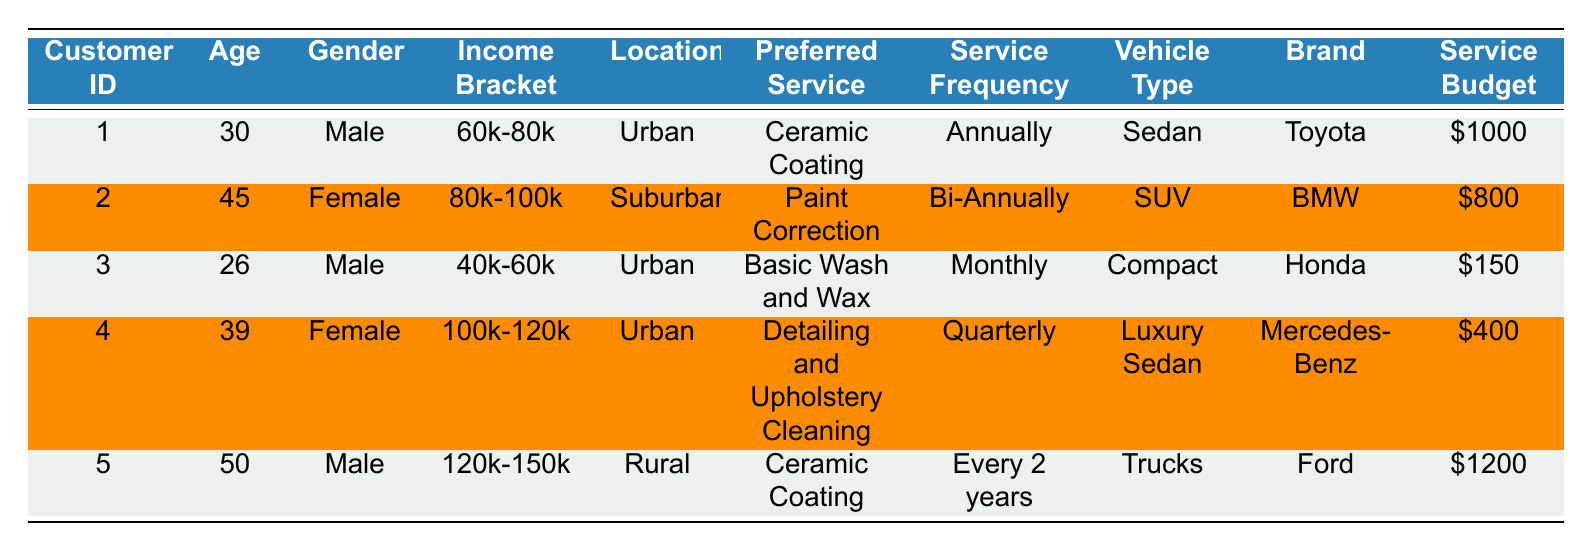What is the preferred service for the customer with ID 1? By looking at the table, the preferred service associated with customer ID 1 is "Ceramic Coating."
Answer: Ceramic Coating How many customers are located in Urban areas? Reviewing the location data in the table, customers with IDs 1, 3, 4 are located in Urban areas, making it a total of 3 customers.
Answer: 3 What is the service budget for the female customer who prefers Paint Correction? From the table, the female customer whose preferred service is "Paint Correction" has a service budget of $800, identified by customer ID 2.
Answer: 800 Is there a customer who prefers Basic Wash and Wax? Yes, there is a customer (customer ID 3) who has indicated "Basic Wash and Wax" as their preferred service.
Answer: Yes What is the average service budget of all customers? To find the average, sum the service budgets: 1000 + 800 + 150 + 400 + 1200 = 2550. Then divide by the number of customers (5), resulting in an average of 2550 / 5 = 510.
Answer: 510 Which age group has the highest service budget based on the data? Analyzing the service budgets by age group, the 50-year-old customer (customer ID 5) has the highest budget of $1200, compared to others. Thus, the age group 50 has the highest budget.
Answer: 50 Do any customers have a frequency of service that is more than twice a year? From the table, customer ID 2's frequency is bi-annually and customer ID 4's is quarterly, which means no customer has a frequency of service more than twice a year.
Answer: No What is the service frequency of the customer with the highest income bracket? Customer ID 5, who is in the income bracket of $120k-$150k, has a service frequency of "Every 2 years."
Answer: Every 2 years How many vehicles from the dataset are identified as SUVs? Examining the table, only customer ID 2 owns an SUV, indicated in the vehicle type column. Therefore, there is only one SUV.
Answer: 1 